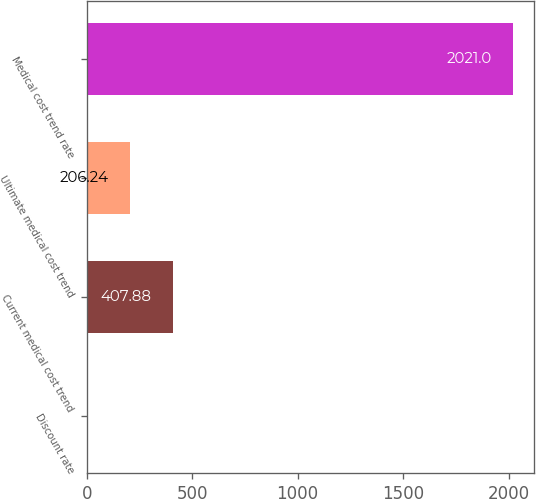Convert chart. <chart><loc_0><loc_0><loc_500><loc_500><bar_chart><fcel>Discount rate<fcel>Current medical cost trend<fcel>Ultimate medical cost trend<fcel>Medical cost trend rate<nl><fcel>4.6<fcel>407.88<fcel>206.24<fcel>2021<nl></chart> 